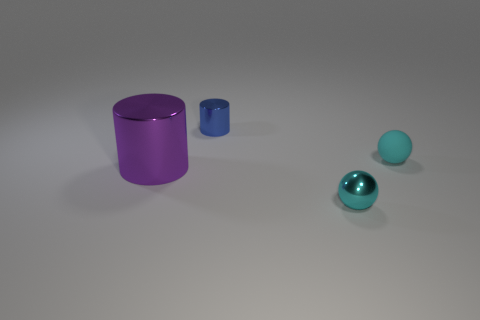What color is the shiny cylinder that is to the right of the big purple thing left of the tiny cylinder?
Provide a succinct answer. Blue. Are there fewer cyan shiny blocks than rubber spheres?
Offer a terse response. Yes. What number of other shiny things have the same shape as the large purple metal thing?
Provide a succinct answer. 1. There is a metallic sphere that is the same size as the rubber ball; what is its color?
Your answer should be compact. Cyan. Are there the same number of purple cylinders in front of the tiny blue shiny thing and tiny blue cylinders in front of the purple metallic thing?
Offer a very short reply. No. Are there any purple metal objects of the same size as the blue object?
Make the answer very short. No. How big is the purple shiny cylinder?
Offer a terse response. Large. Is the number of tiny blue objects that are to the right of the small cyan metallic thing the same as the number of tiny purple matte things?
Your answer should be compact. Yes. How many other objects are there of the same color as the matte ball?
Provide a succinct answer. 1. The metal object that is both in front of the blue thing and on the right side of the large cylinder is what color?
Ensure brevity in your answer.  Cyan. 